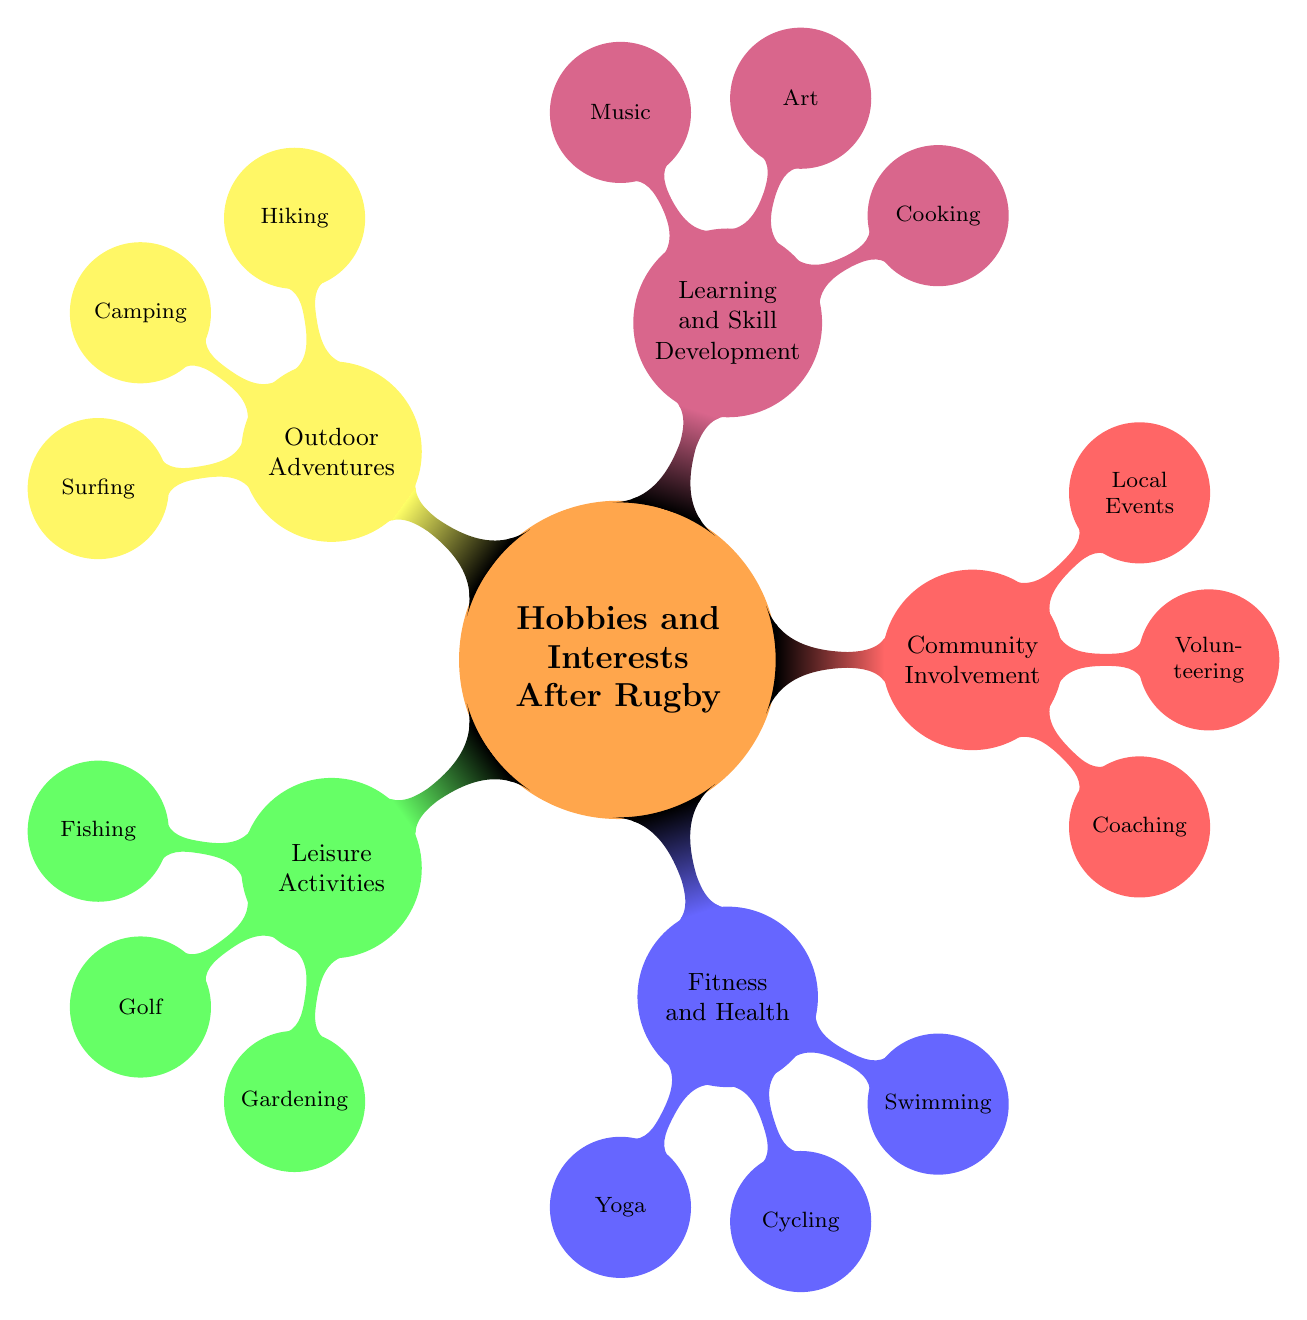What are some activities listed under Leisure Activities? The "Leisure Activities" node has three child nodes listed: "Fishing," "Golf," and "Gardening."
Answer: Fishing, Golf, Gardening How many main categories are represented in the diagram? There are five main categories identified: Leisure Activities, Fitness and Health, Community Involvement, Learning and Skill Development, and Outdoor Adventures.
Answer: 5 Which activity is associated with community involvement? The node "Coaching" is linked under the "Community Involvement" category.
Answer: Coaching What is the specific location mentioned for yoga classes? The description under the "Yoga" node states that classes are available at the "Maclean Yoga Studio."
Answer: Maclean Yoga Studio Which hobby combines physical fitness with exploring nature? "Cycling" is the activity that combines physical fitness while also allowing individuals to explore scenic routes like the Clarence River Route.
Answer: Cycling Which is the only activity that relates to learning a skill? The "Music" node under "Learning and Skill Development" indicates that one can learn to play guitar at the Grafton Music Academy.
Answer: Music How many activities are listed under Outdoor Adventures? There are three activities specified under the "Outdoor Adventures" category: "Hiking," "Camping," and "Surfing."
Answer: 3 Which two categories share a focus on health and physical activity? The "Fitness and Health" category and the "Outdoor Adventures" category both include activities that focus on promoting health and physical activity.
Answer: Fitness and Health, Outdoor Adventures 